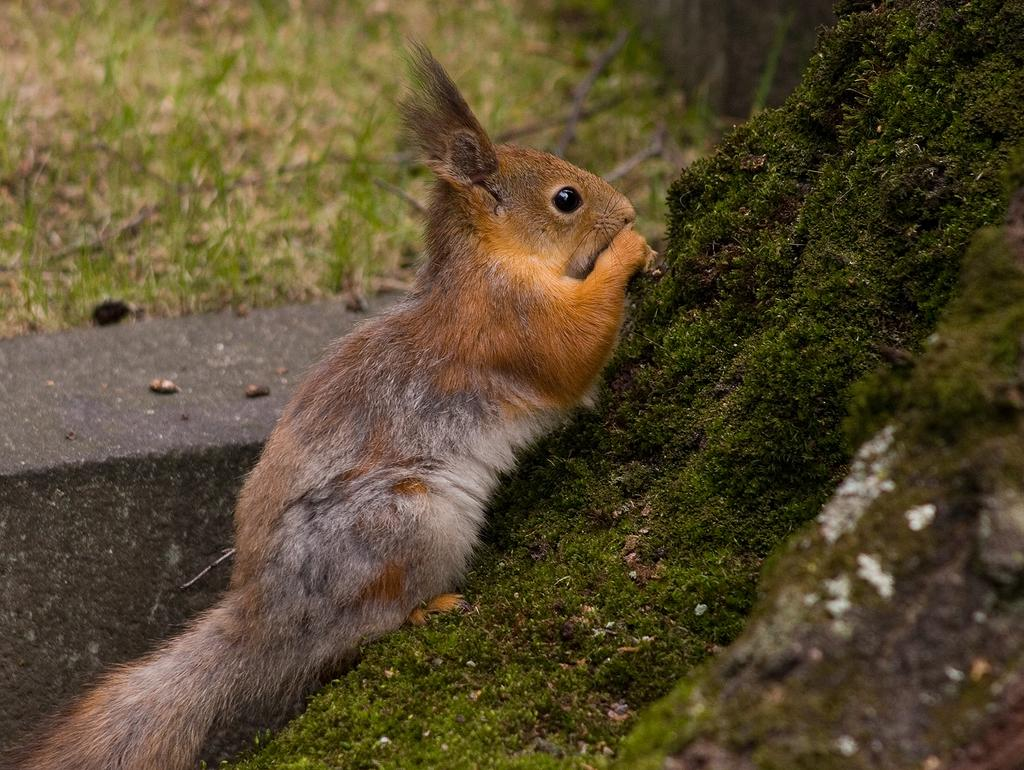What animal can be seen in the image? There is a squirrel in the image. What surface is the squirrel on? The squirrel is on the moss. What type of natural feature is visible in the background of the image? There is a rock in the background of the image. What type of vegetation is visible in the background of the image? There is grass visible in the background of the image. What type of flame can be seen on the squirrel's tail in the image? There is no flame present on the squirrel's tail in the image. 